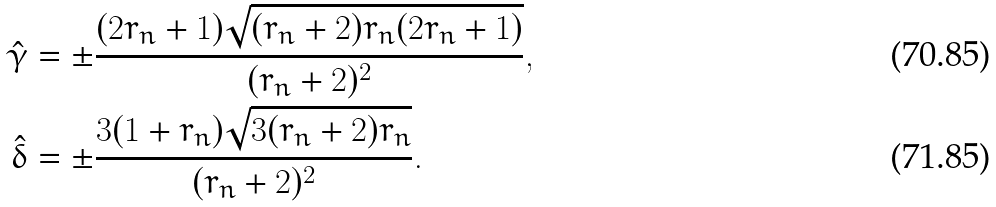Convert formula to latex. <formula><loc_0><loc_0><loc_500><loc_500>\hat { \gamma } & = \pm \frac { ( 2 r _ { n } + 1 ) \sqrt { ( r _ { n } + 2 ) r _ { n } ( 2 r _ { n } + 1 ) } } { ( r _ { n } + 2 ) ^ { 2 } } , \\ \hat { \delta } & = \pm \frac { 3 ( 1 + r _ { n } ) \sqrt { 3 ( r _ { n } + 2 ) r _ { n } } } { ( r _ { n } + 2 ) ^ { 2 } } .</formula> 